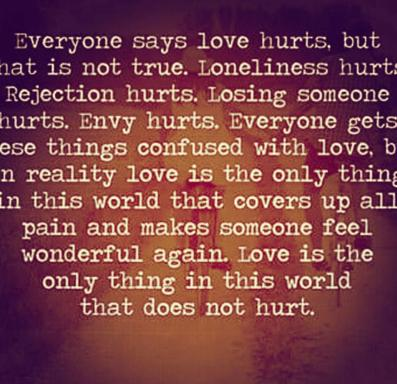Can you explain the symbolism of the butterfly in the context of the image's message about love? The butterfly in the image symbolizes transformation and the potential for growth and rebirth. In the context of love, it suggests that through love, individuals can transform their experiences of pain into something beautiful and empowering, much like a caterpillar transforms into a butterfly. 